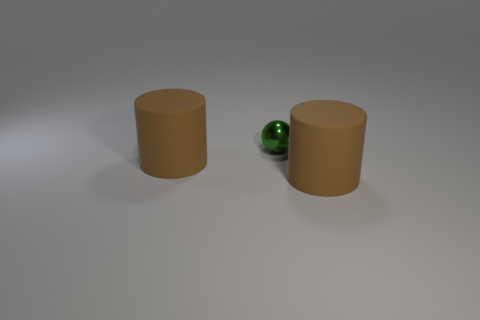Subtract 2 cylinders. How many cylinders are left? 0 Add 1 small green metal objects. How many objects exist? 4 Subtract all cylinders. How many objects are left? 1 Add 2 green metallic objects. How many green metallic objects are left? 3 Add 1 small cyan metallic things. How many small cyan metallic things exist? 1 Subtract 1 brown cylinders. How many objects are left? 2 Subtract all brown balls. Subtract all blue blocks. How many balls are left? 1 Subtract all yellow blocks. How many red cylinders are left? 0 Subtract all cylinders. Subtract all small green spheres. How many objects are left? 0 